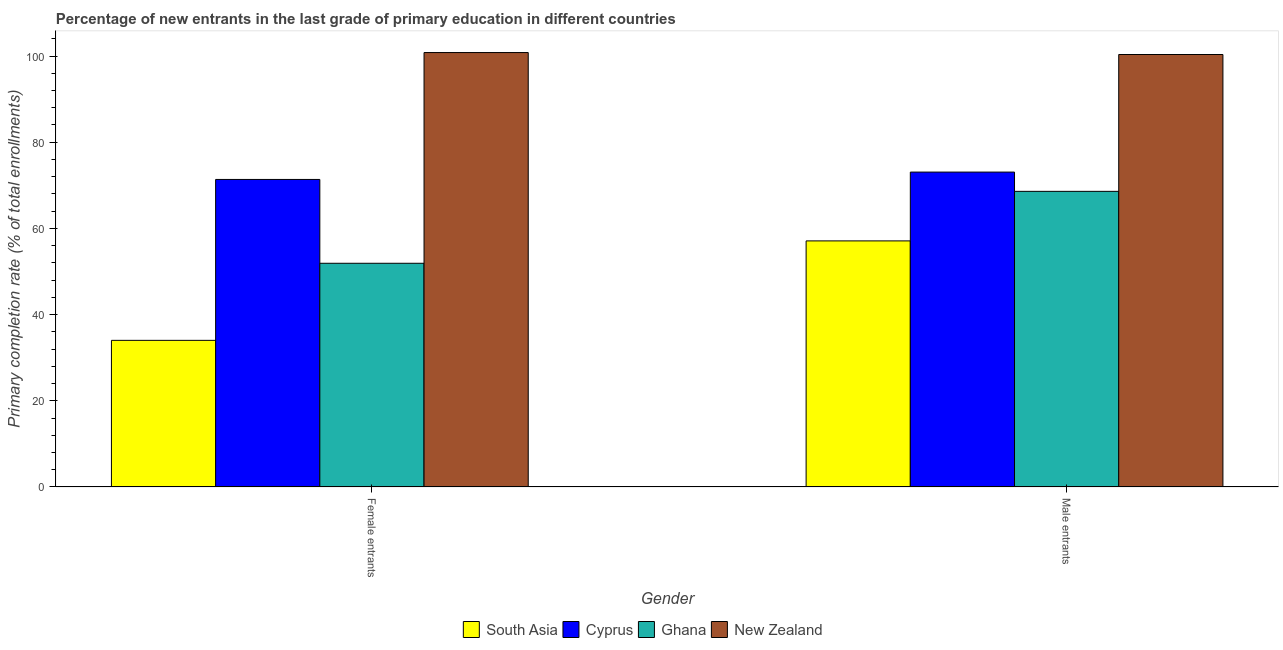How many groups of bars are there?
Provide a succinct answer. 2. Are the number of bars per tick equal to the number of legend labels?
Your answer should be very brief. Yes. Are the number of bars on each tick of the X-axis equal?
Offer a very short reply. Yes. How many bars are there on the 1st tick from the left?
Your answer should be very brief. 4. How many bars are there on the 1st tick from the right?
Your answer should be compact. 4. What is the label of the 1st group of bars from the left?
Keep it short and to the point. Female entrants. What is the primary completion rate of male entrants in Cyprus?
Ensure brevity in your answer.  73.07. Across all countries, what is the maximum primary completion rate of male entrants?
Your response must be concise. 100.35. Across all countries, what is the minimum primary completion rate of female entrants?
Offer a very short reply. 34.03. In which country was the primary completion rate of male entrants maximum?
Provide a succinct answer. New Zealand. What is the total primary completion rate of female entrants in the graph?
Your response must be concise. 258.1. What is the difference between the primary completion rate of male entrants in South Asia and that in Cyprus?
Offer a terse response. -15.96. What is the difference between the primary completion rate of female entrants in New Zealand and the primary completion rate of male entrants in South Asia?
Your response must be concise. 43.7. What is the average primary completion rate of male entrants per country?
Make the answer very short. 74.78. What is the difference between the primary completion rate of male entrants and primary completion rate of female entrants in South Asia?
Your answer should be compact. 23.08. What is the ratio of the primary completion rate of female entrants in South Asia to that in New Zealand?
Your answer should be compact. 0.34. In how many countries, is the primary completion rate of male entrants greater than the average primary completion rate of male entrants taken over all countries?
Your answer should be compact. 1. What does the 1st bar from the left in Female entrants represents?
Give a very brief answer. South Asia. How many bars are there?
Your response must be concise. 8. Are all the bars in the graph horizontal?
Provide a short and direct response. No. How many countries are there in the graph?
Keep it short and to the point. 4. What is the difference between two consecutive major ticks on the Y-axis?
Offer a very short reply. 20. Are the values on the major ticks of Y-axis written in scientific E-notation?
Give a very brief answer. No. Does the graph contain any zero values?
Ensure brevity in your answer.  No. Does the graph contain grids?
Provide a short and direct response. No. How many legend labels are there?
Keep it short and to the point. 4. How are the legend labels stacked?
Offer a terse response. Horizontal. What is the title of the graph?
Give a very brief answer. Percentage of new entrants in the last grade of primary education in different countries. What is the label or title of the X-axis?
Your answer should be compact. Gender. What is the label or title of the Y-axis?
Ensure brevity in your answer.  Primary completion rate (% of total enrollments). What is the Primary completion rate (% of total enrollments) of South Asia in Female entrants?
Offer a terse response. 34.03. What is the Primary completion rate (% of total enrollments) in Cyprus in Female entrants?
Provide a short and direct response. 71.36. What is the Primary completion rate (% of total enrollments) in Ghana in Female entrants?
Ensure brevity in your answer.  51.91. What is the Primary completion rate (% of total enrollments) in New Zealand in Female entrants?
Keep it short and to the point. 100.81. What is the Primary completion rate (% of total enrollments) of South Asia in Male entrants?
Provide a succinct answer. 57.1. What is the Primary completion rate (% of total enrollments) of Cyprus in Male entrants?
Keep it short and to the point. 73.07. What is the Primary completion rate (% of total enrollments) of Ghana in Male entrants?
Give a very brief answer. 68.6. What is the Primary completion rate (% of total enrollments) in New Zealand in Male entrants?
Provide a short and direct response. 100.35. Across all Gender, what is the maximum Primary completion rate (% of total enrollments) of South Asia?
Offer a very short reply. 57.1. Across all Gender, what is the maximum Primary completion rate (% of total enrollments) of Cyprus?
Your response must be concise. 73.07. Across all Gender, what is the maximum Primary completion rate (% of total enrollments) in Ghana?
Provide a short and direct response. 68.6. Across all Gender, what is the maximum Primary completion rate (% of total enrollments) of New Zealand?
Provide a succinct answer. 100.81. Across all Gender, what is the minimum Primary completion rate (% of total enrollments) in South Asia?
Provide a short and direct response. 34.03. Across all Gender, what is the minimum Primary completion rate (% of total enrollments) of Cyprus?
Your answer should be very brief. 71.36. Across all Gender, what is the minimum Primary completion rate (% of total enrollments) of Ghana?
Provide a succinct answer. 51.91. Across all Gender, what is the minimum Primary completion rate (% of total enrollments) in New Zealand?
Give a very brief answer. 100.35. What is the total Primary completion rate (% of total enrollments) in South Asia in the graph?
Provide a short and direct response. 91.13. What is the total Primary completion rate (% of total enrollments) in Cyprus in the graph?
Give a very brief answer. 144.43. What is the total Primary completion rate (% of total enrollments) in Ghana in the graph?
Provide a short and direct response. 120.51. What is the total Primary completion rate (% of total enrollments) of New Zealand in the graph?
Ensure brevity in your answer.  201.16. What is the difference between the Primary completion rate (% of total enrollments) in South Asia in Female entrants and that in Male entrants?
Your response must be concise. -23.08. What is the difference between the Primary completion rate (% of total enrollments) in Cyprus in Female entrants and that in Male entrants?
Your answer should be compact. -1.71. What is the difference between the Primary completion rate (% of total enrollments) in Ghana in Female entrants and that in Male entrants?
Your answer should be very brief. -16.69. What is the difference between the Primary completion rate (% of total enrollments) of New Zealand in Female entrants and that in Male entrants?
Make the answer very short. 0.45. What is the difference between the Primary completion rate (% of total enrollments) of South Asia in Female entrants and the Primary completion rate (% of total enrollments) of Cyprus in Male entrants?
Provide a short and direct response. -39.04. What is the difference between the Primary completion rate (% of total enrollments) in South Asia in Female entrants and the Primary completion rate (% of total enrollments) in Ghana in Male entrants?
Your response must be concise. -34.57. What is the difference between the Primary completion rate (% of total enrollments) of South Asia in Female entrants and the Primary completion rate (% of total enrollments) of New Zealand in Male entrants?
Your answer should be very brief. -66.32. What is the difference between the Primary completion rate (% of total enrollments) in Cyprus in Female entrants and the Primary completion rate (% of total enrollments) in Ghana in Male entrants?
Keep it short and to the point. 2.76. What is the difference between the Primary completion rate (% of total enrollments) in Cyprus in Female entrants and the Primary completion rate (% of total enrollments) in New Zealand in Male entrants?
Your answer should be very brief. -28.99. What is the difference between the Primary completion rate (% of total enrollments) of Ghana in Female entrants and the Primary completion rate (% of total enrollments) of New Zealand in Male entrants?
Keep it short and to the point. -48.44. What is the average Primary completion rate (% of total enrollments) of South Asia per Gender?
Your response must be concise. 45.57. What is the average Primary completion rate (% of total enrollments) of Cyprus per Gender?
Keep it short and to the point. 72.21. What is the average Primary completion rate (% of total enrollments) in Ghana per Gender?
Provide a short and direct response. 60.25. What is the average Primary completion rate (% of total enrollments) of New Zealand per Gender?
Your answer should be very brief. 100.58. What is the difference between the Primary completion rate (% of total enrollments) of South Asia and Primary completion rate (% of total enrollments) of Cyprus in Female entrants?
Your answer should be very brief. -37.33. What is the difference between the Primary completion rate (% of total enrollments) in South Asia and Primary completion rate (% of total enrollments) in Ghana in Female entrants?
Keep it short and to the point. -17.88. What is the difference between the Primary completion rate (% of total enrollments) of South Asia and Primary completion rate (% of total enrollments) of New Zealand in Female entrants?
Give a very brief answer. -66.78. What is the difference between the Primary completion rate (% of total enrollments) in Cyprus and Primary completion rate (% of total enrollments) in Ghana in Female entrants?
Your response must be concise. 19.45. What is the difference between the Primary completion rate (% of total enrollments) of Cyprus and Primary completion rate (% of total enrollments) of New Zealand in Female entrants?
Ensure brevity in your answer.  -29.45. What is the difference between the Primary completion rate (% of total enrollments) in Ghana and Primary completion rate (% of total enrollments) in New Zealand in Female entrants?
Provide a succinct answer. -48.9. What is the difference between the Primary completion rate (% of total enrollments) in South Asia and Primary completion rate (% of total enrollments) in Cyprus in Male entrants?
Keep it short and to the point. -15.96. What is the difference between the Primary completion rate (% of total enrollments) of South Asia and Primary completion rate (% of total enrollments) of Ghana in Male entrants?
Give a very brief answer. -11.49. What is the difference between the Primary completion rate (% of total enrollments) in South Asia and Primary completion rate (% of total enrollments) in New Zealand in Male entrants?
Your answer should be very brief. -43.25. What is the difference between the Primary completion rate (% of total enrollments) in Cyprus and Primary completion rate (% of total enrollments) in Ghana in Male entrants?
Provide a succinct answer. 4.47. What is the difference between the Primary completion rate (% of total enrollments) in Cyprus and Primary completion rate (% of total enrollments) in New Zealand in Male entrants?
Ensure brevity in your answer.  -27.28. What is the difference between the Primary completion rate (% of total enrollments) in Ghana and Primary completion rate (% of total enrollments) in New Zealand in Male entrants?
Your answer should be very brief. -31.75. What is the ratio of the Primary completion rate (% of total enrollments) of South Asia in Female entrants to that in Male entrants?
Give a very brief answer. 0.6. What is the ratio of the Primary completion rate (% of total enrollments) in Cyprus in Female entrants to that in Male entrants?
Provide a succinct answer. 0.98. What is the ratio of the Primary completion rate (% of total enrollments) of Ghana in Female entrants to that in Male entrants?
Your answer should be compact. 0.76. What is the difference between the highest and the second highest Primary completion rate (% of total enrollments) in South Asia?
Give a very brief answer. 23.08. What is the difference between the highest and the second highest Primary completion rate (% of total enrollments) in Cyprus?
Keep it short and to the point. 1.71. What is the difference between the highest and the second highest Primary completion rate (% of total enrollments) in Ghana?
Keep it short and to the point. 16.69. What is the difference between the highest and the second highest Primary completion rate (% of total enrollments) in New Zealand?
Provide a short and direct response. 0.45. What is the difference between the highest and the lowest Primary completion rate (% of total enrollments) in South Asia?
Your answer should be compact. 23.08. What is the difference between the highest and the lowest Primary completion rate (% of total enrollments) in Cyprus?
Provide a succinct answer. 1.71. What is the difference between the highest and the lowest Primary completion rate (% of total enrollments) of Ghana?
Your response must be concise. 16.69. What is the difference between the highest and the lowest Primary completion rate (% of total enrollments) in New Zealand?
Ensure brevity in your answer.  0.45. 